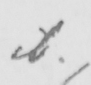Can you tell me what this handwritten text says? ib . 